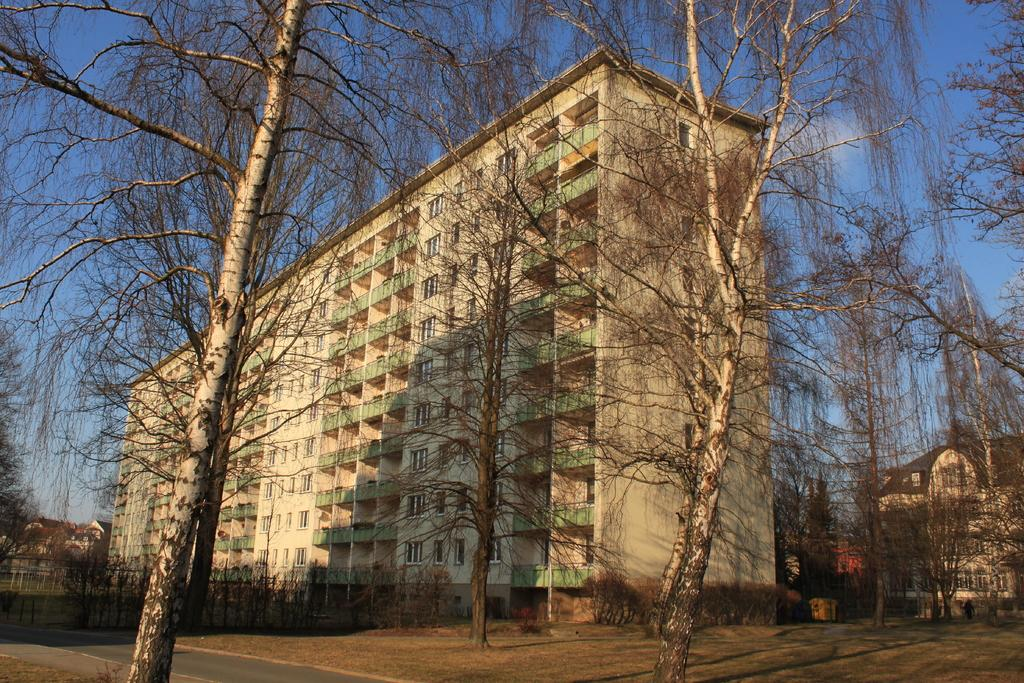What type of vegetation can be seen in the image? There are dry trees and plants visible in the image. What is the purpose of the structure visible in the image? The fence in the image serves as a barrier or boundary. What type of structures can be seen in the image? There are buildings visible in the image. What is visible at the top of the image? The sky is visible at the top of the image. Where is the pot located in the image? There is no pot present in the image. What type of activity is happening at the playground in the image? There is no playground present in the image. 